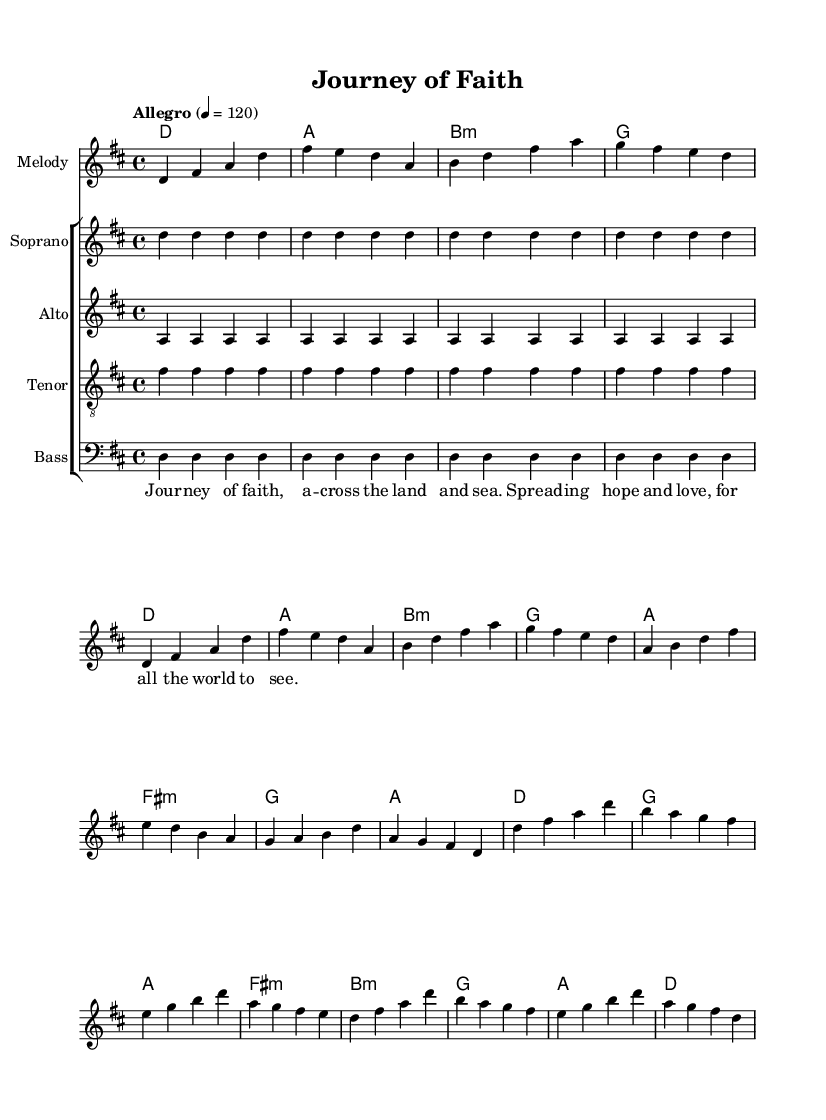What is the key signature of this music? The key signature appears as two sharps on the staff, indicating it is in D major.
Answer: D major What is the time signature of this music? The time signature is indicated at the beginning of the score with a "4/4," meaning there are four beats in each measure.
Answer: 4/4 What is the tempo marking for this piece? The tempo marking is specified as "Allegro" with a metronome marking of 120, indicating a fast tempo.
Answer: Allegro What is the first chord played in the music? By looking at the harmony section, the first chord is a D major chord, which is the first chord listed in the chord names.
Answer: D major How many voices are used in the choir part? The choir part consists of four distinct vocal parts: soprano, alto, tenor, and bass, each written on its own staff.
Answer: Four What is the primary theme conveyed through the lyrics? The lyrics express the journey of spreading hope and love across the land and sea, indicating a theme of faith and exploration.
Answer: Spreading hope and love How many measures are in the chorus section? The chorus section can be counted from the melody part, which contains four measures for the chorus with specific melodic lines.
Answer: Four measures 